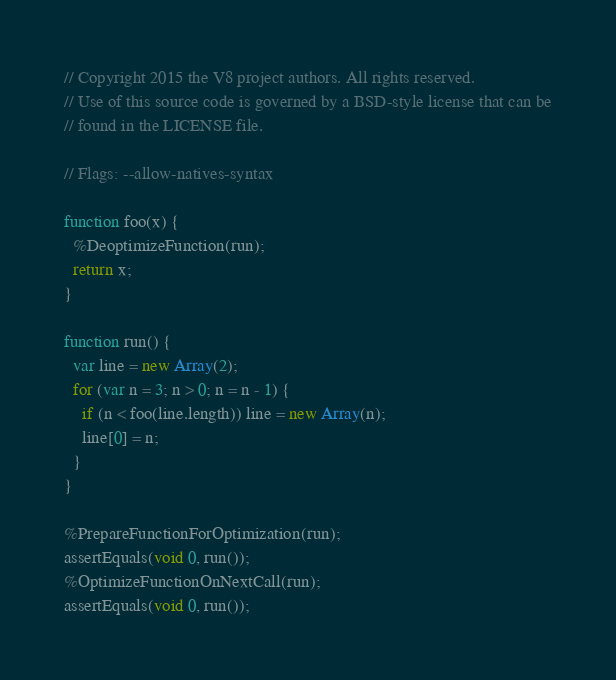<code> <loc_0><loc_0><loc_500><loc_500><_JavaScript_>// Copyright 2015 the V8 project authors. All rights reserved.
// Use of this source code is governed by a BSD-style license that can be
// found in the LICENSE file.

// Flags: --allow-natives-syntax

function foo(x) {
  %DeoptimizeFunction(run);
  return x;
}

function run() {
  var line = new Array(2);
  for (var n = 3; n > 0; n = n - 1) {
    if (n < foo(line.length)) line = new Array(n);
    line[0] = n;
  }
}

%PrepareFunctionForOptimization(run);
assertEquals(void 0, run());
%OptimizeFunctionOnNextCall(run);
assertEquals(void 0, run());
</code> 